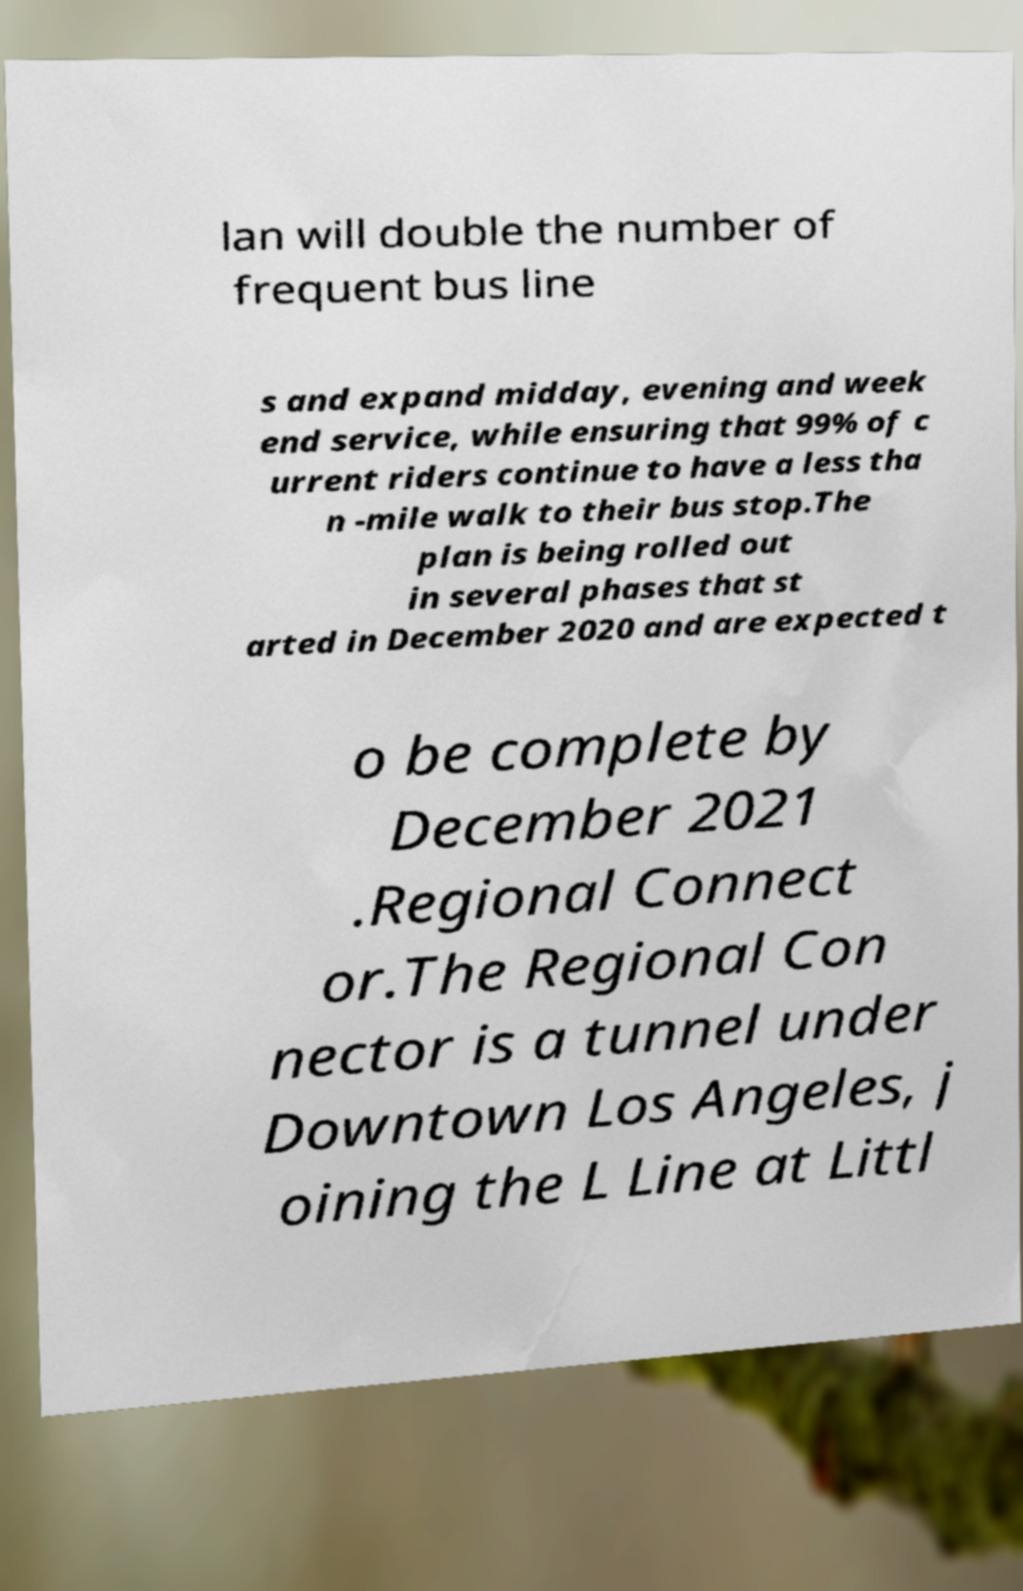For documentation purposes, I need the text within this image transcribed. Could you provide that? lan will double the number of frequent bus line s and expand midday, evening and week end service, while ensuring that 99% of c urrent riders continue to have a less tha n -mile walk to their bus stop.The plan is being rolled out in several phases that st arted in December 2020 and are expected t o be complete by December 2021 .Regional Connect or.The Regional Con nector is a tunnel under Downtown Los Angeles, j oining the L Line at Littl 